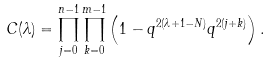<formula> <loc_0><loc_0><loc_500><loc_500>C ( \lambda ) = \prod _ { j = 0 } ^ { n - 1 } \prod _ { k = 0 } ^ { m - 1 } \left ( 1 - q ^ { 2 ( \lambda + 1 - N ) } q ^ { 2 ( j + k ) } \right ) .</formula> 